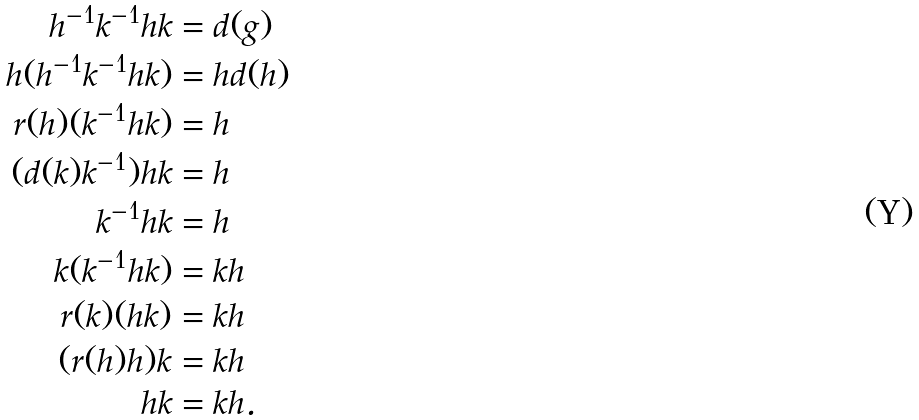<formula> <loc_0><loc_0><loc_500><loc_500>h ^ { - 1 } k ^ { - 1 } h k & = d ( g ) \\ h ( h ^ { - 1 } k ^ { - 1 } h k ) & = h d ( h ) \\ r ( h ) ( k ^ { - 1 } h k ) & = h \\ ( d ( k ) k ^ { - 1 } ) h k & = h \\ k ^ { - 1 } h k & = h \\ k ( k ^ { - 1 } h k ) & = k h \\ r ( k ) ( h k ) & = k h \\ ( r ( h ) h ) k & = k h \\ h k & = k h .</formula> 